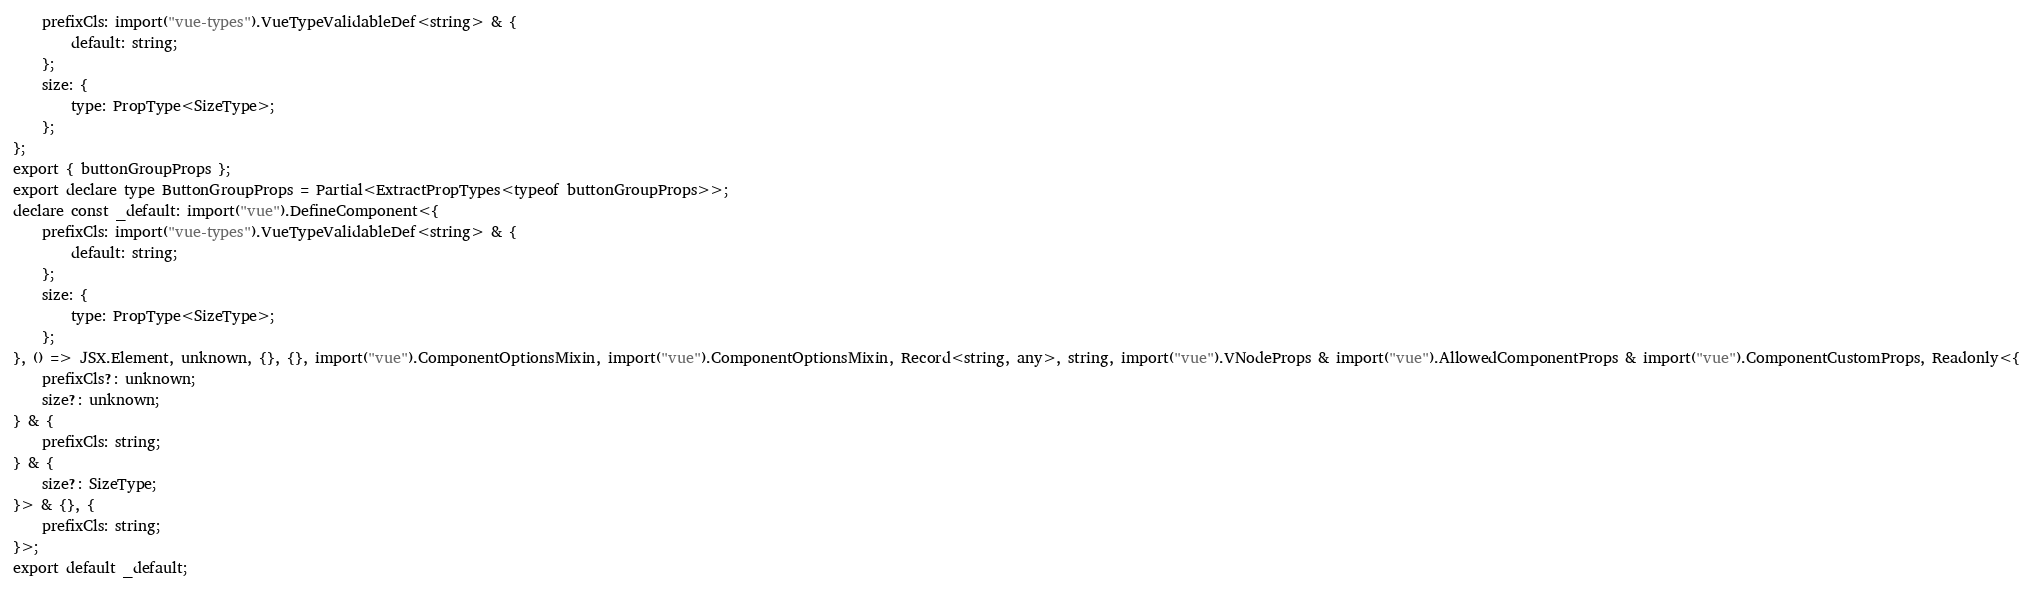<code> <loc_0><loc_0><loc_500><loc_500><_TypeScript_>    prefixCls: import("vue-types").VueTypeValidableDef<string> & {
        default: string;
    };
    size: {
        type: PropType<SizeType>;
    };
};
export { buttonGroupProps };
export declare type ButtonGroupProps = Partial<ExtractPropTypes<typeof buttonGroupProps>>;
declare const _default: import("vue").DefineComponent<{
    prefixCls: import("vue-types").VueTypeValidableDef<string> & {
        default: string;
    };
    size: {
        type: PropType<SizeType>;
    };
}, () => JSX.Element, unknown, {}, {}, import("vue").ComponentOptionsMixin, import("vue").ComponentOptionsMixin, Record<string, any>, string, import("vue").VNodeProps & import("vue").AllowedComponentProps & import("vue").ComponentCustomProps, Readonly<{
    prefixCls?: unknown;
    size?: unknown;
} & {
    prefixCls: string;
} & {
    size?: SizeType;
}> & {}, {
    prefixCls: string;
}>;
export default _default;
</code> 